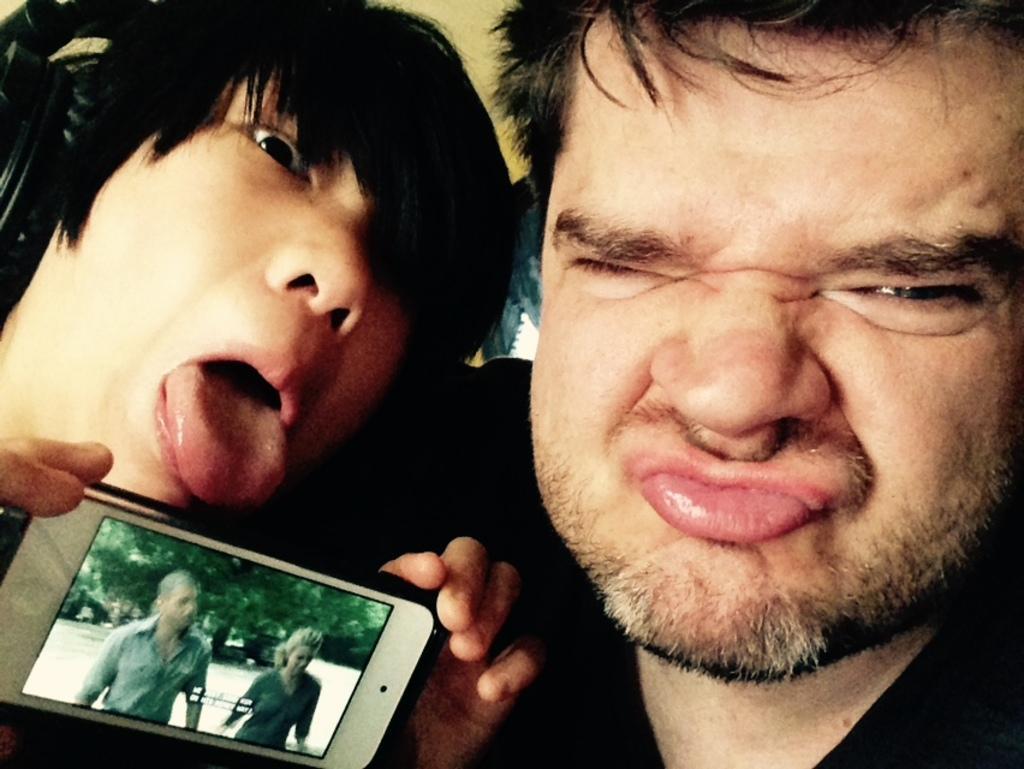How many people are in the image? There are two persons in the image. What are the people doing in the image? The persons are showing face expressions. What is the person on the left holding? The person on the left is holding a mobile. What can be seen on the mobile screen? There are two persons standing on the mobile screen, and a tree is visible in the background. How many rabbits can be seen hopping on the person's wrist in the image? There are no rabbits or wrists visible in the image; it features two persons showing face expressions and one person holding a mobile with a tree in the background. 